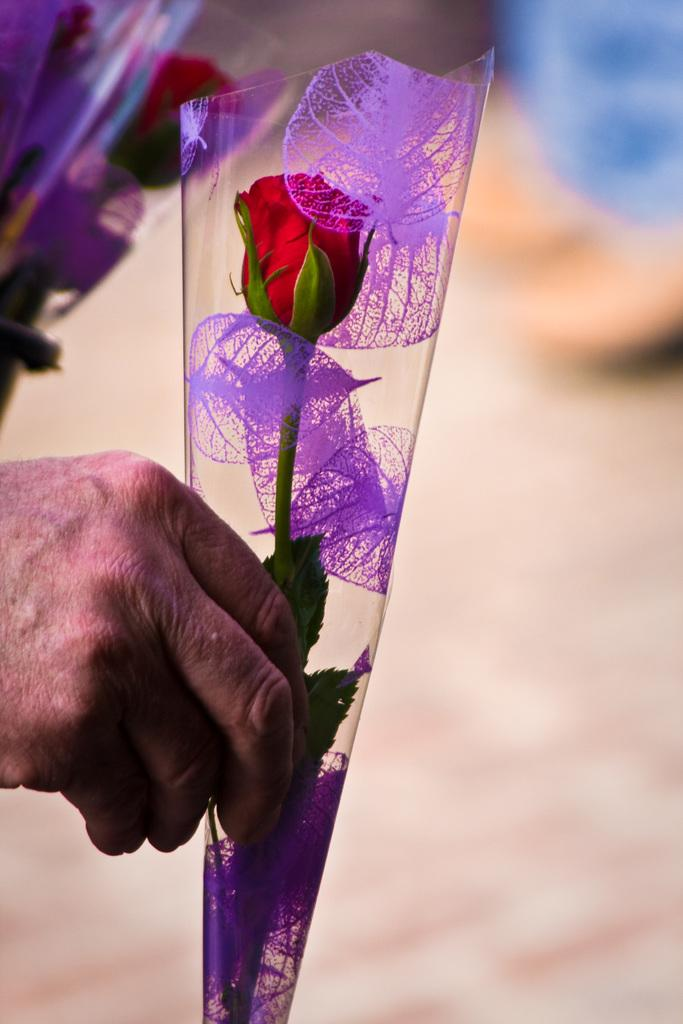What is the main subject of the image? There is a person in the image. What is the person holding in the image? The person is holding a red flower in a cover. What can be seen in the background of the image? There are flowers in covers in the background of the image. What type of brush is being used to paint the airplane in the image? There is no brush or airplane present in the image. What arithmetic problem is being solved by the person in the image? There is no indication of any arithmetic problem being solved in the image. 